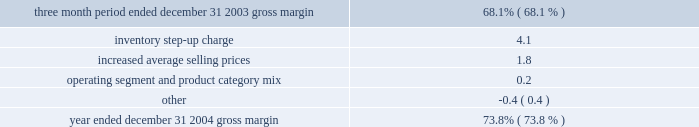Z i m m e r h o l d i n g s , i n c .
A n d s u b s i d i a r i e s 2 0 0 4 f o r m 1 0 - k for the same 2003 period .
Amortization expense increased togross profit $ 39.1 million , or 1.3 percent of sales , during the year ended gross profit as a percentage of net sales was december 31 , 2004 compared to $ 10.9 million , or less than 73.8 percent in 2004 , compared to 72.8 percent in 2003 and 1 percent of sales , during the year ended december 31 , 2003 .
68.1 percent for the three month period ended december 31 , the increase was primarily due to amortization expense 2003 ( the first quarter of combined zimmer and centerpulse related to centerpulse and implex finite lived intangible operations ) .
The table reconciles the gross margin assets .
In addition , during 2004 the company continued to for the year ended december 31 , 2004 and for the three introduce or expand strategic programs and activities .
In month period ended december 31 , 2003 .
2004 , the zimmer institute and its satellite locations were well utilized with over 1400 surgeons trained , compared tothree month period ended december 31 , 2003 500 surgeons trained in 2003 .
These surgeon training costsgross margin 68.1% ( 68.1 % ) are recognized in sg&a .
The company also recognizedinventory step-up charge 4.1 approximately $ 5 million of sarbanes-oxley complianceincreased average selling prices 1.8 expenses , including consultant fees and increased audit fees.operating segment and product category mix 0.2 these increases were partially offset by expense synergiesother ( 0.4 ) realized from the centerpulse acquisition and controlled .
Spending .
The company has begun to realize synergies from the centerpulse acquisition and expects to pursue additionaldecreased centerpulse and implex inventory step-up synergy opportunities .
The company estimates that over thecharges as a percentage of net sales during 2004 next two years it will be able to reduce annual sg&a as a ( $ 59.4 million , or 2.0 percent of net sales ) compared to the percentage of net sales to 38.9 percent or lower , representingthree month period ended december 31 , 2003 ( $ 42.7 million , a 200 basis point improvement over the fourth quarter ofor 6.1 percent of net sales ) and increases in average selling 2003 ( the first quarter of combined zimmer and centerpulseprices were the primary contributors to improved gross operations ) .margins .
In addition , operating segment mix and product acquisition and integration expenses related to thecategory mix both had a positive impact on gross margins acquisitions of centerpulse and implex were $ 81.1 milliondue to higher sales growth in the more profitable americas compared to $ 79.6 million for the same 2003 period andsegment compared to europe and asia pacific , higher sales included $ 24.4 million of sales agent and lease contractgrowth of reconstructive implants and the continued shift to termination expenses , $ 24.2 million of integration consultingpremium products .
Offsetting these favorable impacts were a expenses , $ 9.4 million of employee severance and retentionvariety of other items , including increased royalty expenses expenses , $ 7.8 million of professional fees , $ 5.2 million ofand higher losses on foreign exchange contracts included in personnel expenses and travel for full-time integration teamcost of products sold , partially offset by reduced members , $ 4.3 million of costs related to integrating themanufacturing costs due to automation , vertical integration company 2019s information technology systems , $ 2.9 million ofand process improvements .
Costs related to relocation of facilities , and $ 2.9 million of operating expenses other miscellaneous acquisition and integration expenses .
R&d as a percentage of net sales was 5.6 percent for operating profit , income taxes and net earnings years ended december 31 , 2004 and 2003 .
R&d increased to operating profit for the year ended december 31 , 2004$ 166.7 million from $ 105.8 million reflecting a full year of increased 69 percent to $ 763.2 million from $ 450.7 million incenterpulse research and development expenses and the comparable 2003 period .
Operating profit growth wasincreased spending on active projects focused on areas of driven by zimmer standalone sales growth , operating profitstrategic significance .
The company 2019s pipeline includes 146 contributed by centerpulse , effectively controlled operatingprojects with a total investment equal to or greater than expenses and the absence of in-process research and$ 1 million .
Of the 146 projects , approximately two-thirds development expense in 2004 compared to $ 11.2 million ininvolve new platforms , mis or other technologies .
For 2003 .
These favorable items were partially offset byexample , the company 2019s orthobiological research group in centerpulse and implex inventory step-up of $ 59.4 million inaustin , texas is developing innovative solutions for hip 2004 compared to $ 42.7 million in 2003 and intangible assetfracture and cartilage regeneration .
During 2004 , the amortization of $ 39.1 million in 2004 versus $ 10.9 million incompany delivered more than 40 major development projects 2003.to market .
The company has strategically targeted r&d the effective tax rate on earnings before income taxesspending to be at the high end of what management believes minority interest and cumulative effect of change into be an average of 4-6 percent for the industry .
The accounting principle decreased to 25.9 percent for the yearcompany expects over the next few years to invest in ended december 31 , 2004 from 33.6 percent for the sameresearch and development at approximately 5.5 percent to period in 2003 .
A major component of the decrease6 percent of sales .
( 4.7 percent , or $ 34.5 million ) was the result of revaluingsg&a as a percentage of net sales was 39.9 percent for deferred taxes of acquired centerpulse operations due to athe year ended december 31 , 2004 compared to 38.8 percent reduction in the ongoing swiss tax rate .
The major reasons .
What was the total change in gross margins between december 31 , 2003 and december 312004? 
Computations: (73.8 / 68.1)
Answer: 1.0837. 